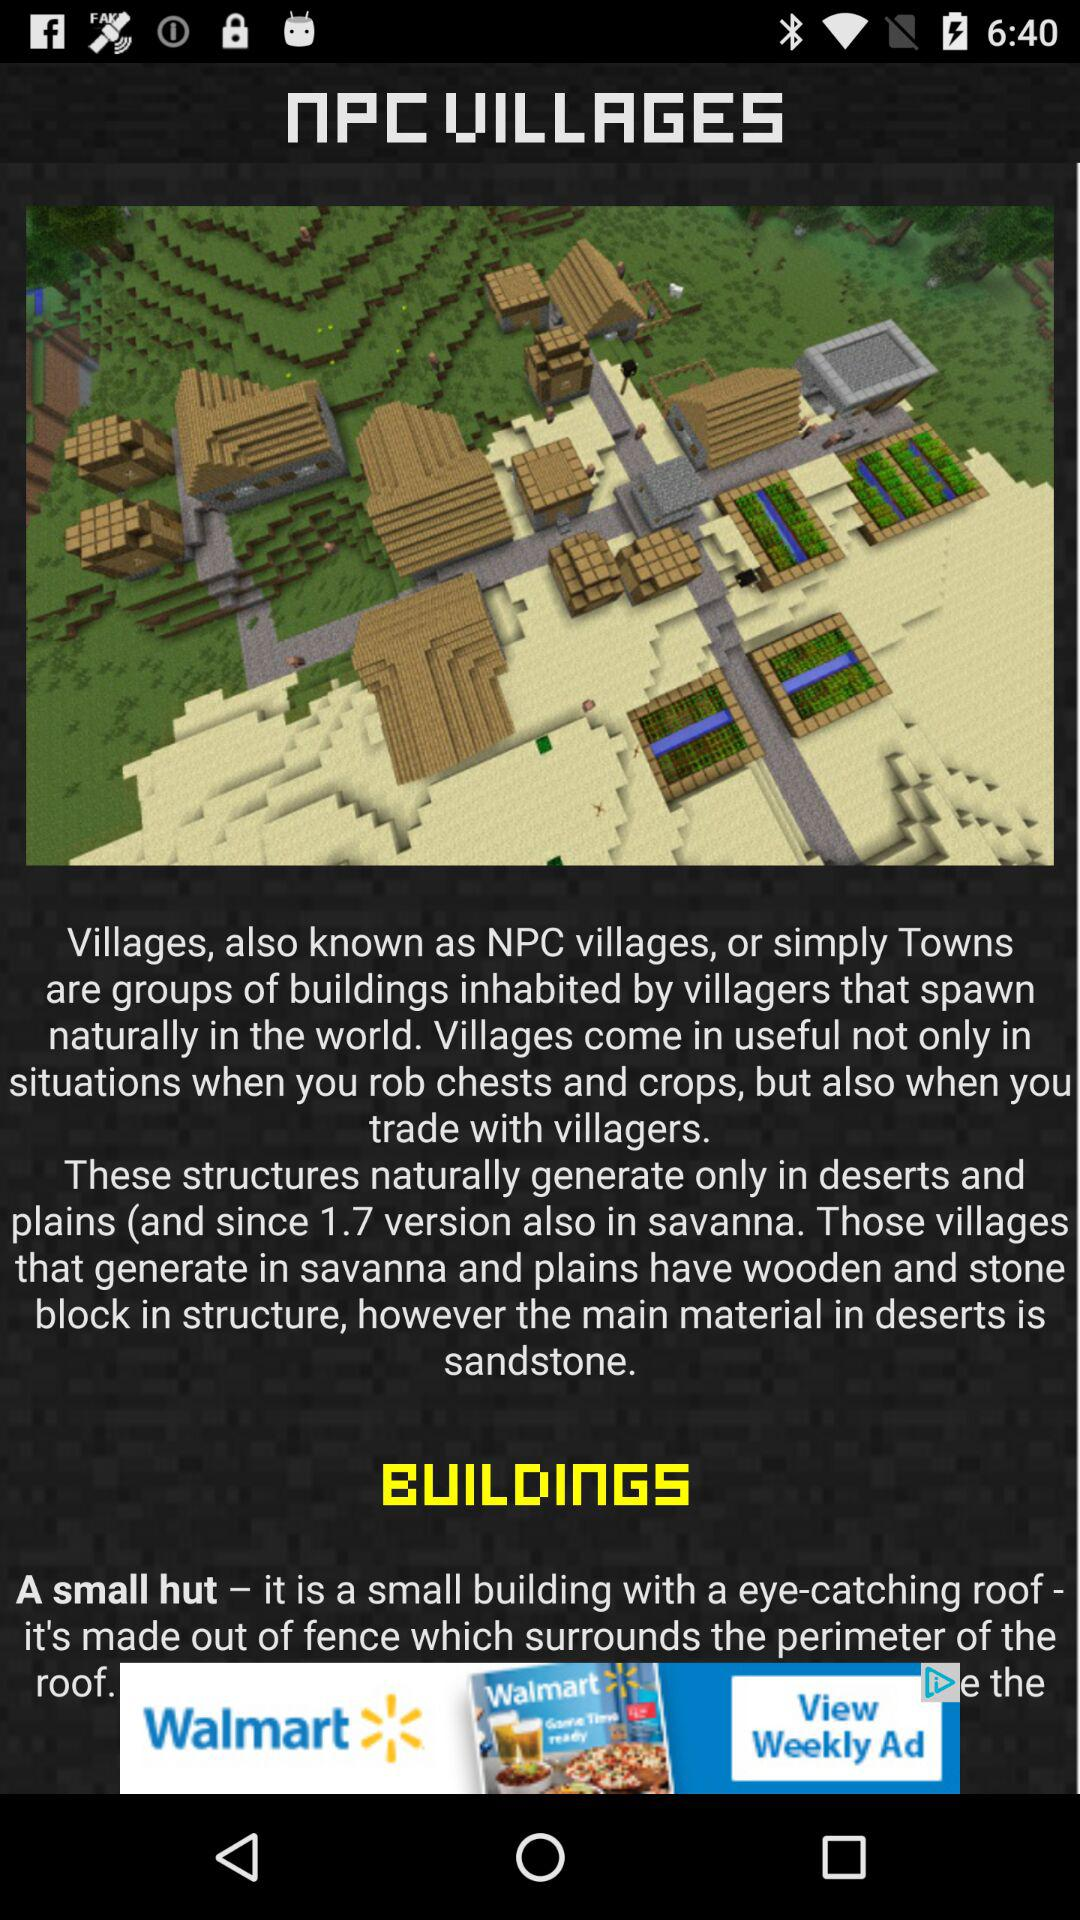What is the name of the villages?
When the provided information is insufficient, respond with <no answer>. <no answer> 